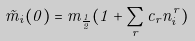<formula> <loc_0><loc_0><loc_500><loc_500>\tilde { m } _ { i } ( 0 ) = m _ { \frac { 1 } { 2 } } ( 1 + \sum _ { r } c _ { r } n _ { i } ^ { r } )</formula> 